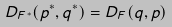<formula> <loc_0><loc_0><loc_500><loc_500>D _ { F ^ { * } } ( p ^ { * } , q ^ { * } ) = D _ { F } ( q , p )</formula> 